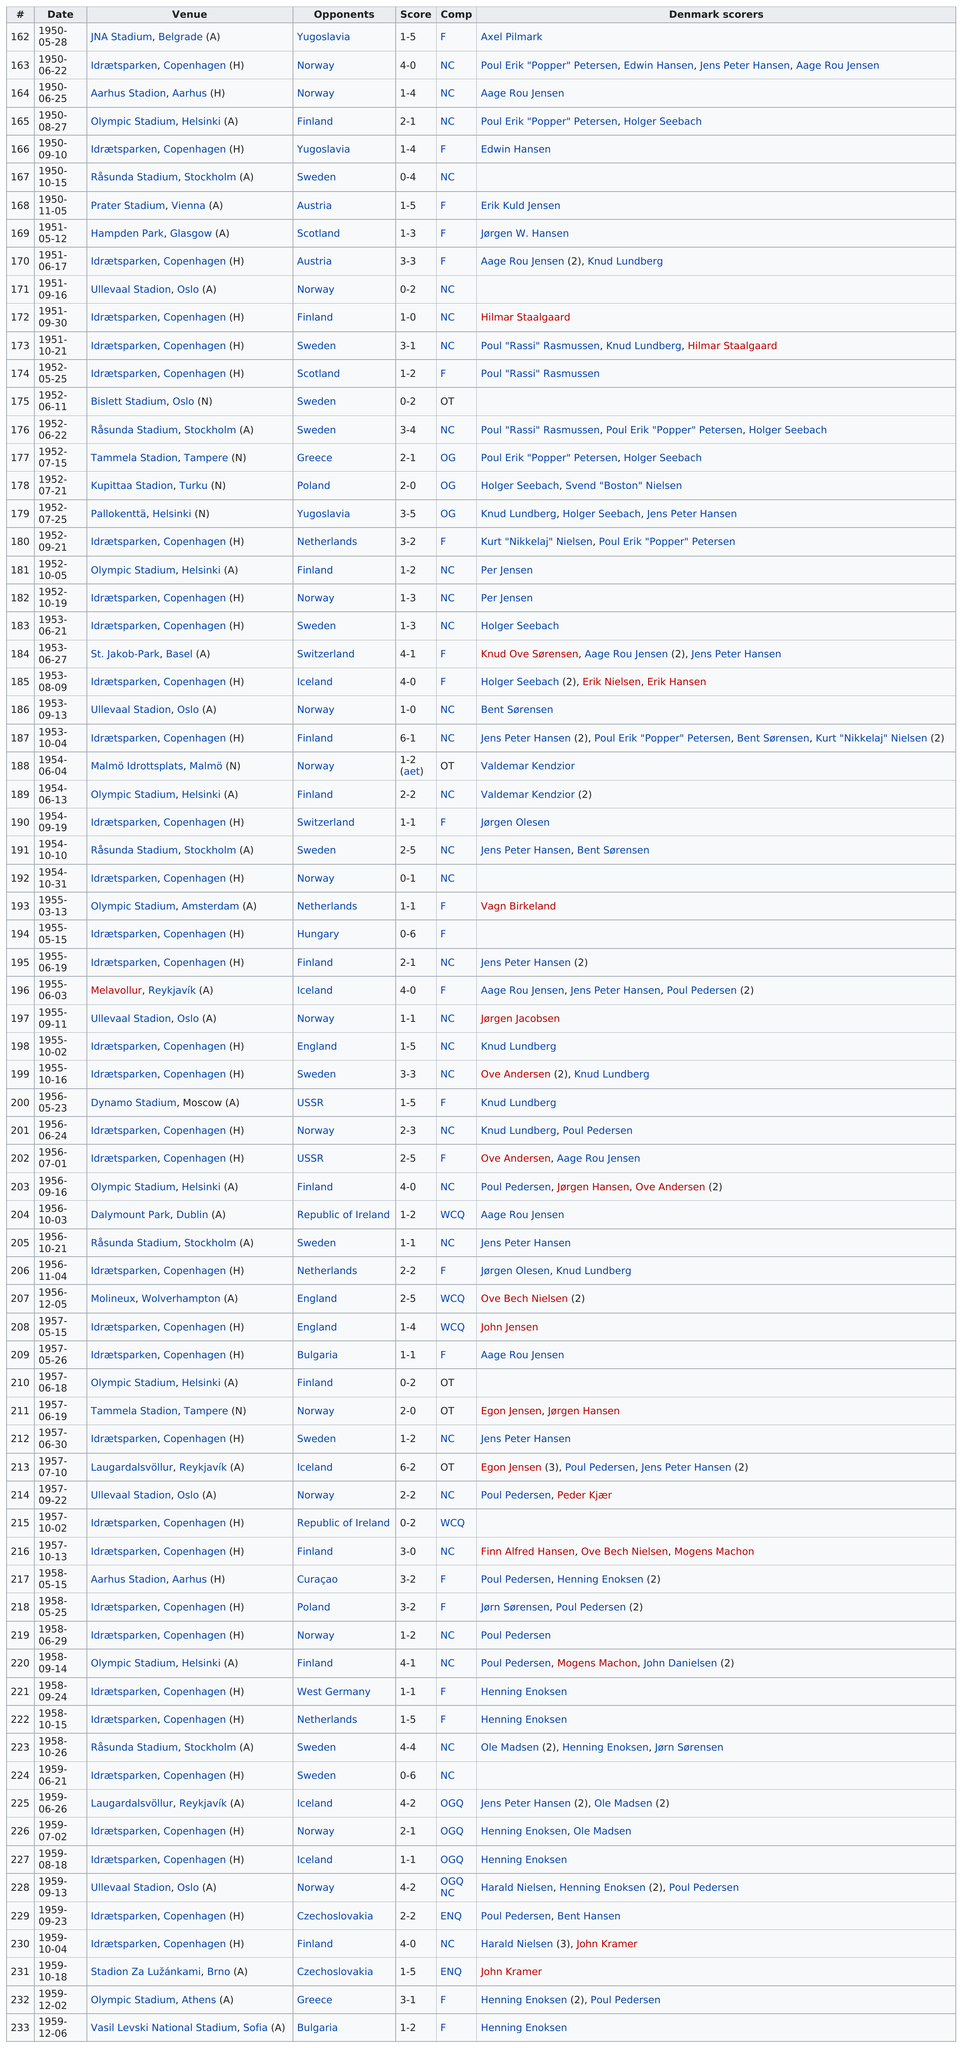Give some essential details in this illustration. The venue located right below JNA Stadium in Belgrade is Idrætsparken in Copenhagen. The final score of the previous game between these two teams revealed a significant difference of 1. Rasmussen first scored in the year 1951. On August 27th, 1950, the venue preceding Olympic Stadium in the schedule was listed as Aarhus Stadion, Aarhus. The first opponent listed on this chart is Yugoslavia. 